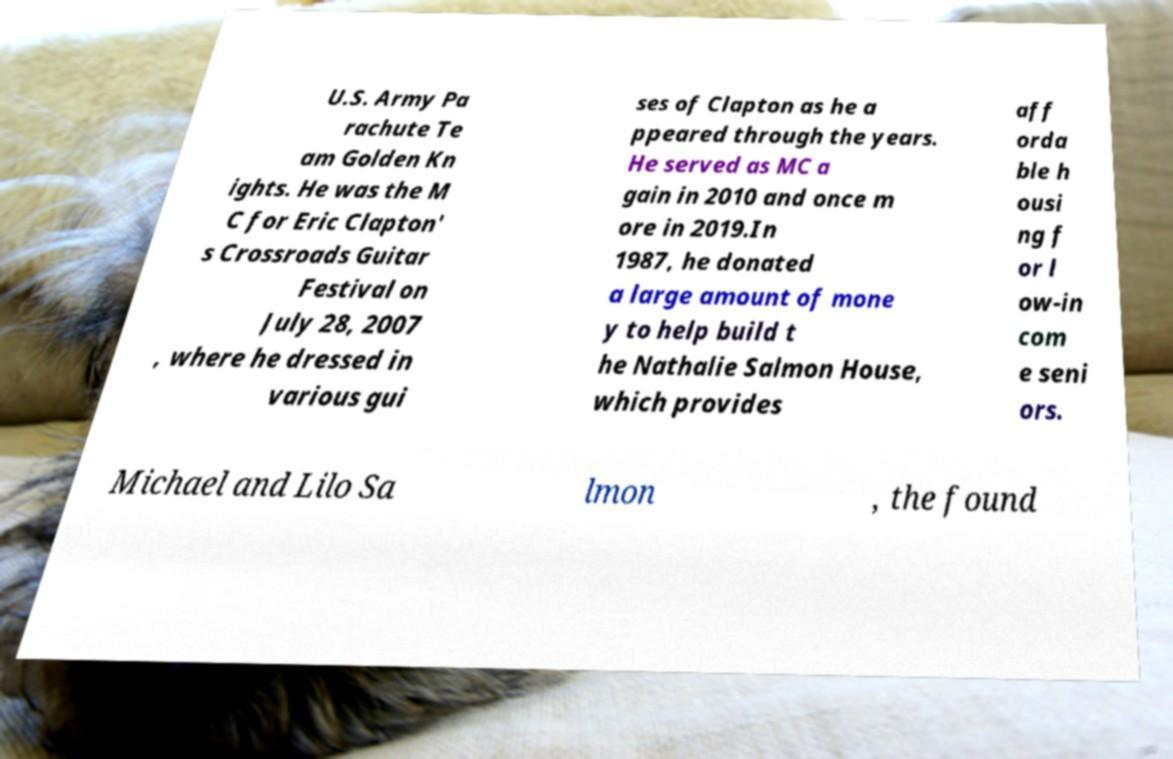Please identify and transcribe the text found in this image. U.S. Army Pa rachute Te am Golden Kn ights. He was the M C for Eric Clapton' s Crossroads Guitar Festival on July 28, 2007 , where he dressed in various gui ses of Clapton as he a ppeared through the years. He served as MC a gain in 2010 and once m ore in 2019.In 1987, he donated a large amount of mone y to help build t he Nathalie Salmon House, which provides aff orda ble h ousi ng f or l ow-in com e seni ors. Michael and Lilo Sa lmon , the found 